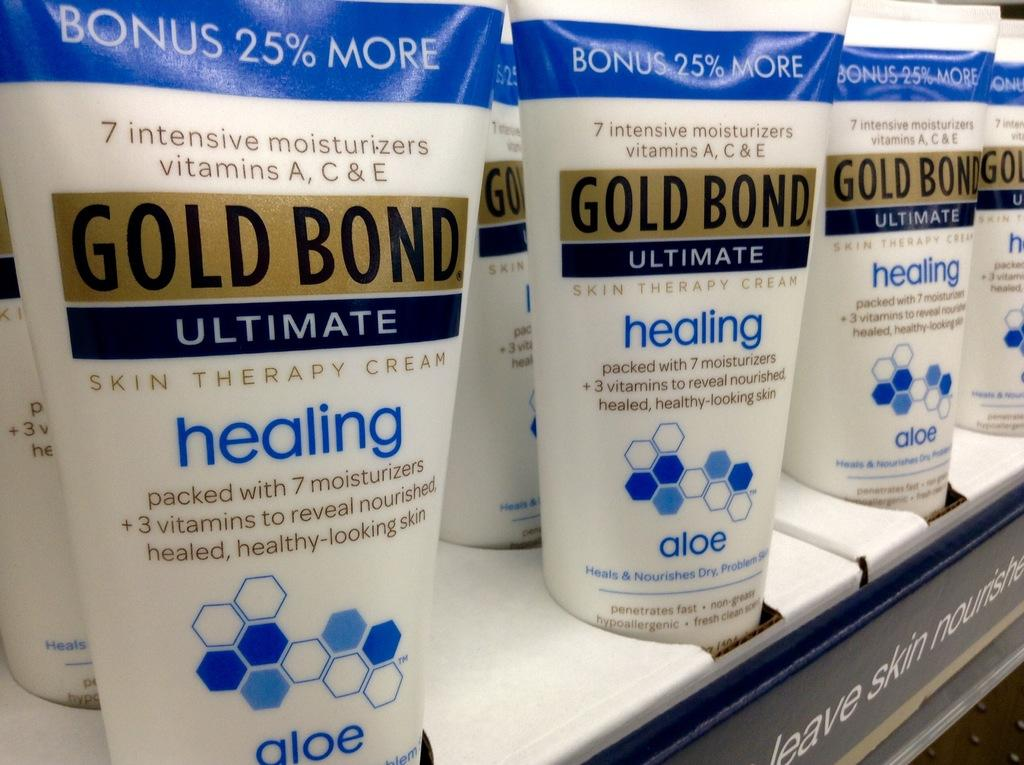<image>
Give a short and clear explanation of the subsequent image. Bottles of Gold Bond ultimate skin therapy cream on display at a store. 